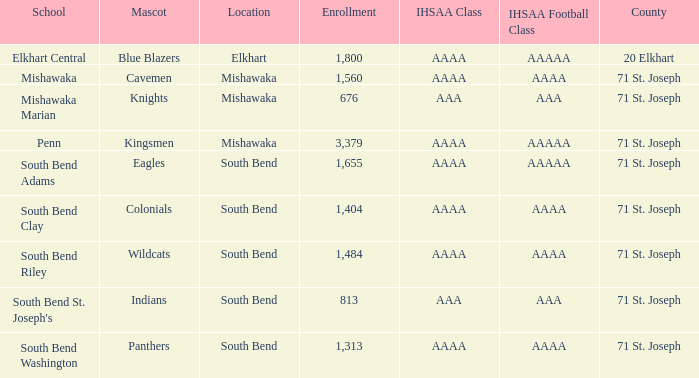What IHSAA Football Class has 20 elkhart as the county? AAAAA. 